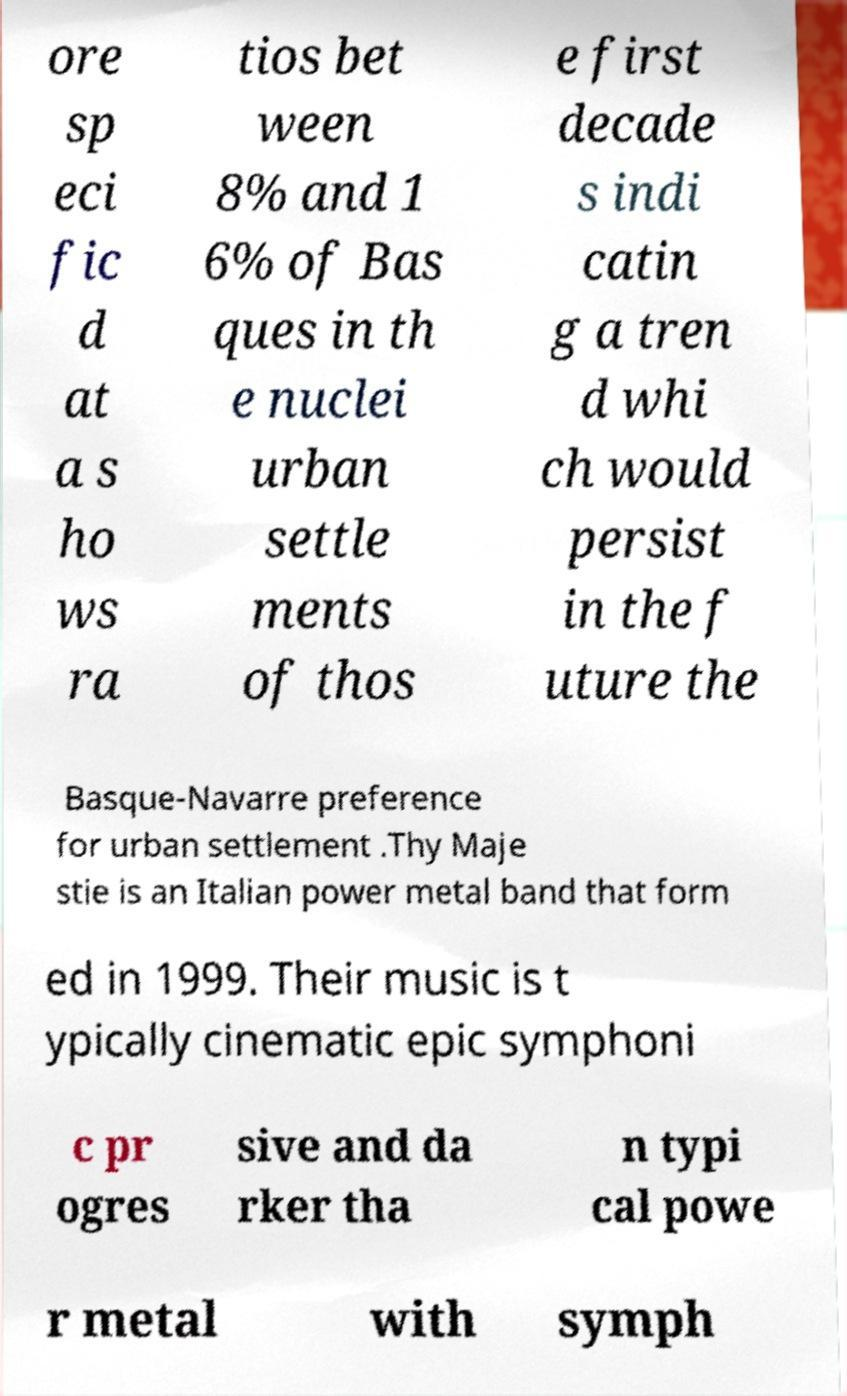Can you read and provide the text displayed in the image?This photo seems to have some interesting text. Can you extract and type it out for me? ore sp eci fic d at a s ho ws ra tios bet ween 8% and 1 6% of Bas ques in th e nuclei urban settle ments of thos e first decade s indi catin g a tren d whi ch would persist in the f uture the Basque-Navarre preference for urban settlement .Thy Maje stie is an Italian power metal band that form ed in 1999. Their music is t ypically cinematic epic symphoni c pr ogres sive and da rker tha n typi cal powe r metal with symph 